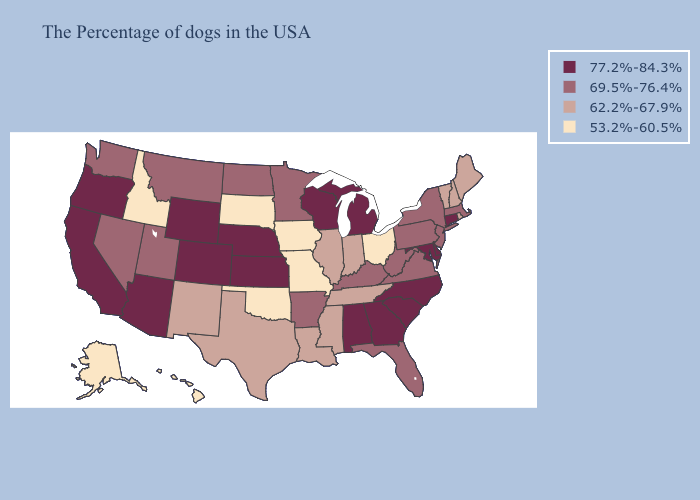Is the legend a continuous bar?
Keep it brief. No. Name the states that have a value in the range 77.2%-84.3%?
Write a very short answer. Connecticut, Delaware, Maryland, North Carolina, South Carolina, Georgia, Michigan, Alabama, Wisconsin, Kansas, Nebraska, Wyoming, Colorado, Arizona, California, Oregon. Does Oklahoma have the same value as Delaware?
Keep it brief. No. How many symbols are there in the legend?
Answer briefly. 4. Does Arkansas have a higher value than Tennessee?
Quick response, please. Yes. Among the states that border Iowa , which have the highest value?
Give a very brief answer. Wisconsin, Nebraska. Which states have the highest value in the USA?
Write a very short answer. Connecticut, Delaware, Maryland, North Carolina, South Carolina, Georgia, Michigan, Alabama, Wisconsin, Kansas, Nebraska, Wyoming, Colorado, Arizona, California, Oregon. Name the states that have a value in the range 53.2%-60.5%?
Keep it brief. Ohio, Missouri, Iowa, Oklahoma, South Dakota, Idaho, Alaska, Hawaii. Does Kansas have the highest value in the USA?
Quick response, please. Yes. What is the highest value in states that border Kentucky?
Be succinct. 69.5%-76.4%. Among the states that border Louisiana , does Texas have the highest value?
Keep it brief. No. What is the highest value in the South ?
Answer briefly. 77.2%-84.3%. Among the states that border Louisiana , does Arkansas have the lowest value?
Answer briefly. No. What is the value of Alaska?
Concise answer only. 53.2%-60.5%. What is the value of Vermont?
Answer briefly. 62.2%-67.9%. 